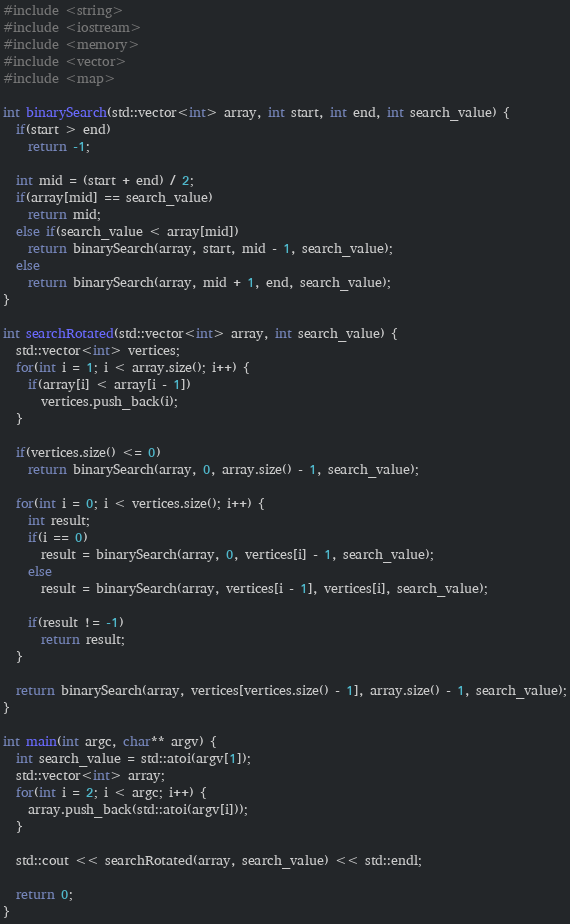<code> <loc_0><loc_0><loc_500><loc_500><_C++_>#include <string>
#include <iostream>
#include <memory>
#include <vector>
#include <map>

int binarySearch(std::vector<int> array, int start, int end, int search_value) {
  if(start > end)
    return -1;

  int mid = (start + end) / 2;
  if(array[mid] == search_value)
    return mid;
  else if(search_value < array[mid])
    return binarySearch(array, start, mid - 1, search_value);
  else
    return binarySearch(array, mid + 1, end, search_value);
}

int searchRotated(std::vector<int> array, int search_value) {
  std::vector<int> vertices;
  for(int i = 1; i < array.size(); i++) {
    if(array[i] < array[i - 1])
      vertices.push_back(i);
  }

  if(vertices.size() <= 0)
    return binarySearch(array, 0, array.size() - 1, search_value);

  for(int i = 0; i < vertices.size(); i++) {
    int result;
    if(i == 0)
      result = binarySearch(array, 0, vertices[i] - 1, search_value);
    else
      result = binarySearch(array, vertices[i - 1], vertices[i], search_value);

    if(result != -1)
      return result;
  }

  return binarySearch(array, vertices[vertices.size() - 1], array.size() - 1, search_value);
}

int main(int argc, char** argv) {
  int search_value = std::atoi(argv[1]);
  std::vector<int> array;
  for(int i = 2; i < argc; i++) {
    array.push_back(std::atoi(argv[i]));
  }

  std::cout << searchRotated(array, search_value) << std::endl;

  return 0;
}</code> 